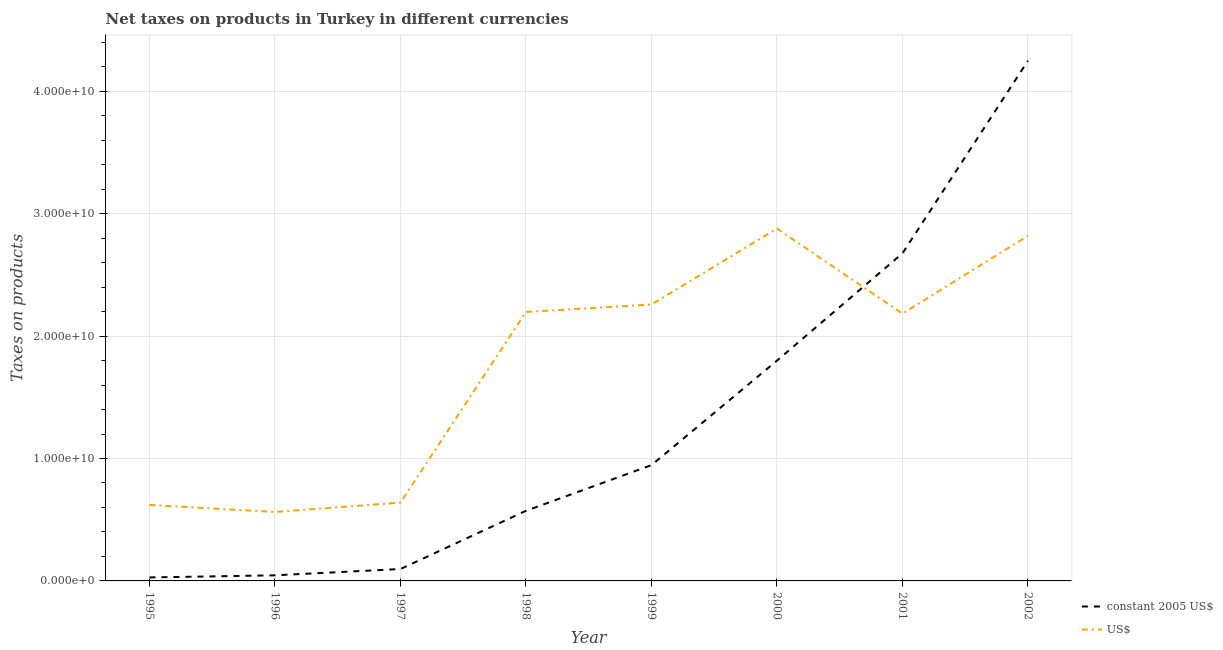Does the line corresponding to net taxes in us$ intersect with the line corresponding to net taxes in constant 2005 us$?
Provide a short and direct response. Yes. What is the net taxes in constant 2005 us$ in 1996?
Ensure brevity in your answer.  4.59e+08. Across all years, what is the maximum net taxes in constant 2005 us$?
Your answer should be compact. 4.25e+1. Across all years, what is the minimum net taxes in us$?
Ensure brevity in your answer.  5.63e+09. What is the total net taxes in us$ in the graph?
Offer a terse response. 1.42e+11. What is the difference between the net taxes in constant 2005 us$ in 2000 and that in 2002?
Ensure brevity in your answer.  -2.45e+1. What is the difference between the net taxes in constant 2005 us$ in 1997 and the net taxes in us$ in 2001?
Keep it short and to the point. -2.09e+1. What is the average net taxes in us$ per year?
Offer a terse response. 1.77e+1. In the year 1996, what is the difference between the net taxes in us$ and net taxes in constant 2005 us$?
Give a very brief answer. 5.18e+09. In how many years, is the net taxes in constant 2005 us$ greater than 30000000000 units?
Offer a terse response. 1. What is the ratio of the net taxes in us$ in 1999 to that in 2000?
Your answer should be very brief. 0.78. Is the difference between the net taxes in us$ in 2001 and 2002 greater than the difference between the net taxes in constant 2005 us$ in 2001 and 2002?
Ensure brevity in your answer.  Yes. What is the difference between the highest and the second highest net taxes in constant 2005 us$?
Offer a very short reply. 1.57e+1. What is the difference between the highest and the lowest net taxes in us$?
Keep it short and to the point. 2.31e+1. In how many years, is the net taxes in constant 2005 us$ greater than the average net taxes in constant 2005 us$ taken over all years?
Offer a terse response. 3. Is the sum of the net taxes in us$ in 1997 and 2000 greater than the maximum net taxes in constant 2005 us$ across all years?
Keep it short and to the point. No. Is the net taxes in constant 2005 us$ strictly greater than the net taxes in us$ over the years?
Provide a succinct answer. No. How many lines are there?
Make the answer very short. 2. How many years are there in the graph?
Make the answer very short. 8. What is the difference between two consecutive major ticks on the Y-axis?
Your answer should be compact. 1.00e+1. Does the graph contain grids?
Make the answer very short. Yes. What is the title of the graph?
Keep it short and to the point. Net taxes on products in Turkey in different currencies. What is the label or title of the X-axis?
Ensure brevity in your answer.  Year. What is the label or title of the Y-axis?
Your answer should be compact. Taxes on products. What is the Taxes on products in constant 2005 US$ in 1995?
Provide a short and direct response. 2.84e+08. What is the Taxes on products in US$ in 1995?
Your response must be concise. 6.20e+09. What is the Taxes on products of constant 2005 US$ in 1996?
Your answer should be very brief. 4.59e+08. What is the Taxes on products in US$ in 1996?
Make the answer very short. 5.63e+09. What is the Taxes on products of constant 2005 US$ in 1997?
Provide a short and direct response. 9.72e+08. What is the Taxes on products of US$ in 1997?
Give a very brief answer. 6.40e+09. What is the Taxes on products in constant 2005 US$ in 1998?
Ensure brevity in your answer.  5.73e+09. What is the Taxes on products in US$ in 1998?
Provide a short and direct response. 2.20e+1. What is the Taxes on products of constant 2005 US$ in 1999?
Your answer should be compact. 9.46e+09. What is the Taxes on products in US$ in 1999?
Provide a succinct answer. 2.26e+1. What is the Taxes on products in constant 2005 US$ in 2000?
Make the answer very short. 1.80e+1. What is the Taxes on products of US$ in 2000?
Ensure brevity in your answer.  2.88e+1. What is the Taxes on products of constant 2005 US$ in 2001?
Make the answer very short. 2.68e+1. What is the Taxes on products of US$ in 2001?
Make the answer very short. 2.18e+1. What is the Taxes on products in constant 2005 US$ in 2002?
Make the answer very short. 4.25e+1. What is the Taxes on products of US$ in 2002?
Give a very brief answer. 2.82e+1. Across all years, what is the maximum Taxes on products in constant 2005 US$?
Ensure brevity in your answer.  4.25e+1. Across all years, what is the maximum Taxes on products in US$?
Give a very brief answer. 2.88e+1. Across all years, what is the minimum Taxes on products of constant 2005 US$?
Offer a terse response. 2.84e+08. Across all years, what is the minimum Taxes on products of US$?
Your answer should be very brief. 5.63e+09. What is the total Taxes on products in constant 2005 US$ in the graph?
Your answer should be compact. 1.04e+11. What is the total Taxes on products in US$ in the graph?
Your answer should be compact. 1.42e+11. What is the difference between the Taxes on products in constant 2005 US$ in 1995 and that in 1996?
Provide a short and direct response. -1.74e+08. What is the difference between the Taxes on products of US$ in 1995 and that in 1996?
Make the answer very short. 5.70e+08. What is the difference between the Taxes on products in constant 2005 US$ in 1995 and that in 1997?
Provide a succinct answer. -6.88e+08. What is the difference between the Taxes on products of US$ in 1995 and that in 1997?
Make the answer very short. -1.95e+08. What is the difference between the Taxes on products of constant 2005 US$ in 1995 and that in 1998?
Provide a succinct answer. -5.44e+09. What is the difference between the Taxes on products in US$ in 1995 and that in 1998?
Offer a terse response. -1.58e+1. What is the difference between the Taxes on products of constant 2005 US$ in 1995 and that in 1999?
Your response must be concise. -9.17e+09. What is the difference between the Taxes on products of US$ in 1995 and that in 1999?
Offer a terse response. -1.64e+1. What is the difference between the Taxes on products in constant 2005 US$ in 1995 and that in 2000?
Make the answer very short. -1.77e+1. What is the difference between the Taxes on products in US$ in 1995 and that in 2000?
Your answer should be compact. -2.26e+1. What is the difference between the Taxes on products in constant 2005 US$ in 1995 and that in 2001?
Your response must be concise. -2.65e+1. What is the difference between the Taxes on products in US$ in 1995 and that in 2001?
Provide a succinct answer. -1.56e+1. What is the difference between the Taxes on products of constant 2005 US$ in 1995 and that in 2002?
Offer a very short reply. -4.22e+1. What is the difference between the Taxes on products of US$ in 1995 and that in 2002?
Your response must be concise. -2.20e+1. What is the difference between the Taxes on products in constant 2005 US$ in 1996 and that in 1997?
Ensure brevity in your answer.  -5.13e+08. What is the difference between the Taxes on products of US$ in 1996 and that in 1997?
Provide a short and direct response. -7.65e+08. What is the difference between the Taxes on products in constant 2005 US$ in 1996 and that in 1998?
Offer a very short reply. -5.27e+09. What is the difference between the Taxes on products of US$ in 1996 and that in 1998?
Keep it short and to the point. -1.63e+1. What is the difference between the Taxes on products in constant 2005 US$ in 1996 and that in 1999?
Your answer should be compact. -9.00e+09. What is the difference between the Taxes on products of US$ in 1996 and that in 1999?
Give a very brief answer. -1.69e+1. What is the difference between the Taxes on products in constant 2005 US$ in 1996 and that in 2000?
Your answer should be very brief. -1.75e+1. What is the difference between the Taxes on products of US$ in 1996 and that in 2000?
Provide a short and direct response. -2.31e+1. What is the difference between the Taxes on products of constant 2005 US$ in 1996 and that in 2001?
Provide a short and direct response. -2.63e+1. What is the difference between the Taxes on products in US$ in 1996 and that in 2001?
Give a very brief answer. -1.62e+1. What is the difference between the Taxes on products of constant 2005 US$ in 1996 and that in 2002?
Keep it short and to the point. -4.20e+1. What is the difference between the Taxes on products of US$ in 1996 and that in 2002?
Make the answer very short. -2.26e+1. What is the difference between the Taxes on products of constant 2005 US$ in 1997 and that in 1998?
Ensure brevity in your answer.  -4.75e+09. What is the difference between the Taxes on products of US$ in 1997 and that in 1998?
Make the answer very short. -1.56e+1. What is the difference between the Taxes on products in constant 2005 US$ in 1997 and that in 1999?
Your answer should be compact. -8.48e+09. What is the difference between the Taxes on products of US$ in 1997 and that in 1999?
Provide a succinct answer. -1.62e+1. What is the difference between the Taxes on products of constant 2005 US$ in 1997 and that in 2000?
Make the answer very short. -1.70e+1. What is the difference between the Taxes on products in US$ in 1997 and that in 2000?
Offer a terse response. -2.24e+1. What is the difference between the Taxes on products of constant 2005 US$ in 1997 and that in 2001?
Ensure brevity in your answer.  -2.58e+1. What is the difference between the Taxes on products of US$ in 1997 and that in 2001?
Keep it short and to the point. -1.54e+1. What is the difference between the Taxes on products in constant 2005 US$ in 1997 and that in 2002?
Offer a very short reply. -4.15e+1. What is the difference between the Taxes on products in US$ in 1997 and that in 2002?
Provide a short and direct response. -2.18e+1. What is the difference between the Taxes on products in constant 2005 US$ in 1998 and that in 1999?
Ensure brevity in your answer.  -3.73e+09. What is the difference between the Taxes on products of US$ in 1998 and that in 1999?
Your answer should be compact. -6.13e+08. What is the difference between the Taxes on products of constant 2005 US$ in 1998 and that in 2000?
Offer a very short reply. -1.23e+1. What is the difference between the Taxes on products of US$ in 1998 and that in 2000?
Your answer should be very brief. -6.81e+09. What is the difference between the Taxes on products of constant 2005 US$ in 1998 and that in 2001?
Give a very brief answer. -2.10e+1. What is the difference between the Taxes on products in US$ in 1998 and that in 2001?
Offer a very short reply. 1.37e+08. What is the difference between the Taxes on products in constant 2005 US$ in 1998 and that in 2002?
Keep it short and to the point. -3.68e+1. What is the difference between the Taxes on products of US$ in 1998 and that in 2002?
Make the answer very short. -6.22e+09. What is the difference between the Taxes on products in constant 2005 US$ in 1999 and that in 2000?
Keep it short and to the point. -8.54e+09. What is the difference between the Taxes on products in US$ in 1999 and that in 2000?
Your answer should be very brief. -6.20e+09. What is the difference between the Taxes on products of constant 2005 US$ in 1999 and that in 2001?
Provide a succinct answer. -1.73e+1. What is the difference between the Taxes on products in US$ in 1999 and that in 2001?
Offer a terse response. 7.50e+08. What is the difference between the Taxes on products of constant 2005 US$ in 1999 and that in 2002?
Provide a succinct answer. -3.30e+1. What is the difference between the Taxes on products of US$ in 1999 and that in 2002?
Provide a succinct answer. -5.61e+09. What is the difference between the Taxes on products of constant 2005 US$ in 2000 and that in 2001?
Make the answer very short. -8.76e+09. What is the difference between the Taxes on products of US$ in 2000 and that in 2001?
Your answer should be compact. 6.95e+09. What is the difference between the Taxes on products in constant 2005 US$ in 2000 and that in 2002?
Give a very brief answer. -2.45e+1. What is the difference between the Taxes on products of US$ in 2000 and that in 2002?
Provide a short and direct response. 5.90e+08. What is the difference between the Taxes on products in constant 2005 US$ in 2001 and that in 2002?
Offer a very short reply. -1.57e+1. What is the difference between the Taxes on products in US$ in 2001 and that in 2002?
Your answer should be compact. -6.36e+09. What is the difference between the Taxes on products in constant 2005 US$ in 1995 and the Taxes on products in US$ in 1996?
Your response must be concise. -5.35e+09. What is the difference between the Taxes on products of constant 2005 US$ in 1995 and the Taxes on products of US$ in 1997?
Make the answer very short. -6.11e+09. What is the difference between the Taxes on products of constant 2005 US$ in 1995 and the Taxes on products of US$ in 1998?
Offer a very short reply. -2.17e+1. What is the difference between the Taxes on products of constant 2005 US$ in 1995 and the Taxes on products of US$ in 1999?
Your answer should be very brief. -2.23e+1. What is the difference between the Taxes on products in constant 2005 US$ in 1995 and the Taxes on products in US$ in 2000?
Offer a terse response. -2.85e+1. What is the difference between the Taxes on products of constant 2005 US$ in 1995 and the Taxes on products of US$ in 2001?
Your response must be concise. -2.15e+1. What is the difference between the Taxes on products of constant 2005 US$ in 1995 and the Taxes on products of US$ in 2002?
Provide a short and direct response. -2.79e+1. What is the difference between the Taxes on products in constant 2005 US$ in 1996 and the Taxes on products in US$ in 1997?
Offer a terse response. -5.94e+09. What is the difference between the Taxes on products in constant 2005 US$ in 1996 and the Taxes on products in US$ in 1998?
Your response must be concise. -2.15e+1. What is the difference between the Taxes on products in constant 2005 US$ in 1996 and the Taxes on products in US$ in 1999?
Your response must be concise. -2.21e+1. What is the difference between the Taxes on products in constant 2005 US$ in 1996 and the Taxes on products in US$ in 2000?
Give a very brief answer. -2.83e+1. What is the difference between the Taxes on products of constant 2005 US$ in 1996 and the Taxes on products of US$ in 2001?
Provide a succinct answer. -2.14e+1. What is the difference between the Taxes on products in constant 2005 US$ in 1996 and the Taxes on products in US$ in 2002?
Offer a very short reply. -2.77e+1. What is the difference between the Taxes on products of constant 2005 US$ in 1997 and the Taxes on products of US$ in 1998?
Make the answer very short. -2.10e+1. What is the difference between the Taxes on products in constant 2005 US$ in 1997 and the Taxes on products in US$ in 1999?
Ensure brevity in your answer.  -2.16e+1. What is the difference between the Taxes on products in constant 2005 US$ in 1997 and the Taxes on products in US$ in 2000?
Your answer should be very brief. -2.78e+1. What is the difference between the Taxes on products of constant 2005 US$ in 1997 and the Taxes on products of US$ in 2001?
Your answer should be very brief. -2.09e+1. What is the difference between the Taxes on products in constant 2005 US$ in 1997 and the Taxes on products in US$ in 2002?
Offer a very short reply. -2.72e+1. What is the difference between the Taxes on products of constant 2005 US$ in 1998 and the Taxes on products of US$ in 1999?
Provide a succinct answer. -1.69e+1. What is the difference between the Taxes on products of constant 2005 US$ in 1998 and the Taxes on products of US$ in 2000?
Your response must be concise. -2.31e+1. What is the difference between the Taxes on products in constant 2005 US$ in 1998 and the Taxes on products in US$ in 2001?
Provide a succinct answer. -1.61e+1. What is the difference between the Taxes on products in constant 2005 US$ in 1998 and the Taxes on products in US$ in 2002?
Keep it short and to the point. -2.25e+1. What is the difference between the Taxes on products in constant 2005 US$ in 1999 and the Taxes on products in US$ in 2000?
Your response must be concise. -1.93e+1. What is the difference between the Taxes on products in constant 2005 US$ in 1999 and the Taxes on products in US$ in 2001?
Provide a short and direct response. -1.24e+1. What is the difference between the Taxes on products in constant 2005 US$ in 1999 and the Taxes on products in US$ in 2002?
Ensure brevity in your answer.  -1.87e+1. What is the difference between the Taxes on products of constant 2005 US$ in 2000 and the Taxes on products of US$ in 2001?
Offer a terse response. -3.84e+09. What is the difference between the Taxes on products of constant 2005 US$ in 2000 and the Taxes on products of US$ in 2002?
Keep it short and to the point. -1.02e+1. What is the difference between the Taxes on products of constant 2005 US$ in 2001 and the Taxes on products of US$ in 2002?
Provide a succinct answer. -1.44e+09. What is the average Taxes on products of constant 2005 US$ per year?
Keep it short and to the point. 1.30e+1. What is the average Taxes on products of US$ per year?
Your answer should be compact. 1.77e+1. In the year 1995, what is the difference between the Taxes on products in constant 2005 US$ and Taxes on products in US$?
Provide a short and direct response. -5.92e+09. In the year 1996, what is the difference between the Taxes on products of constant 2005 US$ and Taxes on products of US$?
Ensure brevity in your answer.  -5.18e+09. In the year 1997, what is the difference between the Taxes on products in constant 2005 US$ and Taxes on products in US$?
Make the answer very short. -5.43e+09. In the year 1998, what is the difference between the Taxes on products of constant 2005 US$ and Taxes on products of US$?
Provide a succinct answer. -1.62e+1. In the year 1999, what is the difference between the Taxes on products of constant 2005 US$ and Taxes on products of US$?
Your answer should be compact. -1.31e+1. In the year 2000, what is the difference between the Taxes on products in constant 2005 US$ and Taxes on products in US$?
Provide a succinct answer. -1.08e+1. In the year 2001, what is the difference between the Taxes on products in constant 2005 US$ and Taxes on products in US$?
Provide a succinct answer. 4.93e+09. In the year 2002, what is the difference between the Taxes on products of constant 2005 US$ and Taxes on products of US$?
Your response must be concise. 1.43e+1. What is the ratio of the Taxes on products in constant 2005 US$ in 1995 to that in 1996?
Your answer should be compact. 0.62. What is the ratio of the Taxes on products in US$ in 1995 to that in 1996?
Offer a very short reply. 1.1. What is the ratio of the Taxes on products in constant 2005 US$ in 1995 to that in 1997?
Your answer should be very brief. 0.29. What is the ratio of the Taxes on products of US$ in 1995 to that in 1997?
Provide a short and direct response. 0.97. What is the ratio of the Taxes on products of constant 2005 US$ in 1995 to that in 1998?
Keep it short and to the point. 0.05. What is the ratio of the Taxes on products in US$ in 1995 to that in 1998?
Ensure brevity in your answer.  0.28. What is the ratio of the Taxes on products of US$ in 1995 to that in 1999?
Your response must be concise. 0.27. What is the ratio of the Taxes on products of constant 2005 US$ in 1995 to that in 2000?
Offer a terse response. 0.02. What is the ratio of the Taxes on products of US$ in 1995 to that in 2000?
Offer a terse response. 0.22. What is the ratio of the Taxes on products of constant 2005 US$ in 1995 to that in 2001?
Your answer should be very brief. 0.01. What is the ratio of the Taxes on products in US$ in 1995 to that in 2001?
Offer a very short reply. 0.28. What is the ratio of the Taxes on products of constant 2005 US$ in 1995 to that in 2002?
Make the answer very short. 0.01. What is the ratio of the Taxes on products in US$ in 1995 to that in 2002?
Offer a terse response. 0.22. What is the ratio of the Taxes on products of constant 2005 US$ in 1996 to that in 1997?
Keep it short and to the point. 0.47. What is the ratio of the Taxes on products of US$ in 1996 to that in 1997?
Your answer should be very brief. 0.88. What is the ratio of the Taxes on products in constant 2005 US$ in 1996 to that in 1998?
Offer a very short reply. 0.08. What is the ratio of the Taxes on products of US$ in 1996 to that in 1998?
Your answer should be very brief. 0.26. What is the ratio of the Taxes on products of constant 2005 US$ in 1996 to that in 1999?
Provide a short and direct response. 0.05. What is the ratio of the Taxes on products in US$ in 1996 to that in 1999?
Offer a terse response. 0.25. What is the ratio of the Taxes on products of constant 2005 US$ in 1996 to that in 2000?
Keep it short and to the point. 0.03. What is the ratio of the Taxes on products in US$ in 1996 to that in 2000?
Ensure brevity in your answer.  0.2. What is the ratio of the Taxes on products in constant 2005 US$ in 1996 to that in 2001?
Offer a very short reply. 0.02. What is the ratio of the Taxes on products in US$ in 1996 to that in 2001?
Give a very brief answer. 0.26. What is the ratio of the Taxes on products of constant 2005 US$ in 1996 to that in 2002?
Ensure brevity in your answer.  0.01. What is the ratio of the Taxes on products of US$ in 1996 to that in 2002?
Your answer should be compact. 0.2. What is the ratio of the Taxes on products of constant 2005 US$ in 1997 to that in 1998?
Your answer should be compact. 0.17. What is the ratio of the Taxes on products of US$ in 1997 to that in 1998?
Give a very brief answer. 0.29. What is the ratio of the Taxes on products in constant 2005 US$ in 1997 to that in 1999?
Provide a succinct answer. 0.1. What is the ratio of the Taxes on products of US$ in 1997 to that in 1999?
Provide a succinct answer. 0.28. What is the ratio of the Taxes on products in constant 2005 US$ in 1997 to that in 2000?
Give a very brief answer. 0.05. What is the ratio of the Taxes on products in US$ in 1997 to that in 2000?
Offer a very short reply. 0.22. What is the ratio of the Taxes on products in constant 2005 US$ in 1997 to that in 2001?
Your response must be concise. 0.04. What is the ratio of the Taxes on products in US$ in 1997 to that in 2001?
Your answer should be compact. 0.29. What is the ratio of the Taxes on products of constant 2005 US$ in 1997 to that in 2002?
Offer a very short reply. 0.02. What is the ratio of the Taxes on products of US$ in 1997 to that in 2002?
Keep it short and to the point. 0.23. What is the ratio of the Taxes on products of constant 2005 US$ in 1998 to that in 1999?
Make the answer very short. 0.61. What is the ratio of the Taxes on products in US$ in 1998 to that in 1999?
Keep it short and to the point. 0.97. What is the ratio of the Taxes on products in constant 2005 US$ in 1998 to that in 2000?
Ensure brevity in your answer.  0.32. What is the ratio of the Taxes on products of US$ in 1998 to that in 2000?
Your response must be concise. 0.76. What is the ratio of the Taxes on products of constant 2005 US$ in 1998 to that in 2001?
Provide a succinct answer. 0.21. What is the ratio of the Taxes on products in constant 2005 US$ in 1998 to that in 2002?
Your answer should be compact. 0.13. What is the ratio of the Taxes on products in US$ in 1998 to that in 2002?
Provide a short and direct response. 0.78. What is the ratio of the Taxes on products in constant 2005 US$ in 1999 to that in 2000?
Ensure brevity in your answer.  0.53. What is the ratio of the Taxes on products of US$ in 1999 to that in 2000?
Give a very brief answer. 0.78. What is the ratio of the Taxes on products in constant 2005 US$ in 1999 to that in 2001?
Your answer should be very brief. 0.35. What is the ratio of the Taxes on products in US$ in 1999 to that in 2001?
Ensure brevity in your answer.  1.03. What is the ratio of the Taxes on products in constant 2005 US$ in 1999 to that in 2002?
Your answer should be very brief. 0.22. What is the ratio of the Taxes on products of US$ in 1999 to that in 2002?
Offer a very short reply. 0.8. What is the ratio of the Taxes on products of constant 2005 US$ in 2000 to that in 2001?
Ensure brevity in your answer.  0.67. What is the ratio of the Taxes on products of US$ in 2000 to that in 2001?
Your answer should be very brief. 1.32. What is the ratio of the Taxes on products of constant 2005 US$ in 2000 to that in 2002?
Give a very brief answer. 0.42. What is the ratio of the Taxes on products of US$ in 2000 to that in 2002?
Offer a terse response. 1.02. What is the ratio of the Taxes on products in constant 2005 US$ in 2001 to that in 2002?
Give a very brief answer. 0.63. What is the ratio of the Taxes on products in US$ in 2001 to that in 2002?
Provide a succinct answer. 0.77. What is the difference between the highest and the second highest Taxes on products of constant 2005 US$?
Your response must be concise. 1.57e+1. What is the difference between the highest and the second highest Taxes on products of US$?
Offer a very short reply. 5.90e+08. What is the difference between the highest and the lowest Taxes on products in constant 2005 US$?
Give a very brief answer. 4.22e+1. What is the difference between the highest and the lowest Taxes on products of US$?
Your response must be concise. 2.31e+1. 